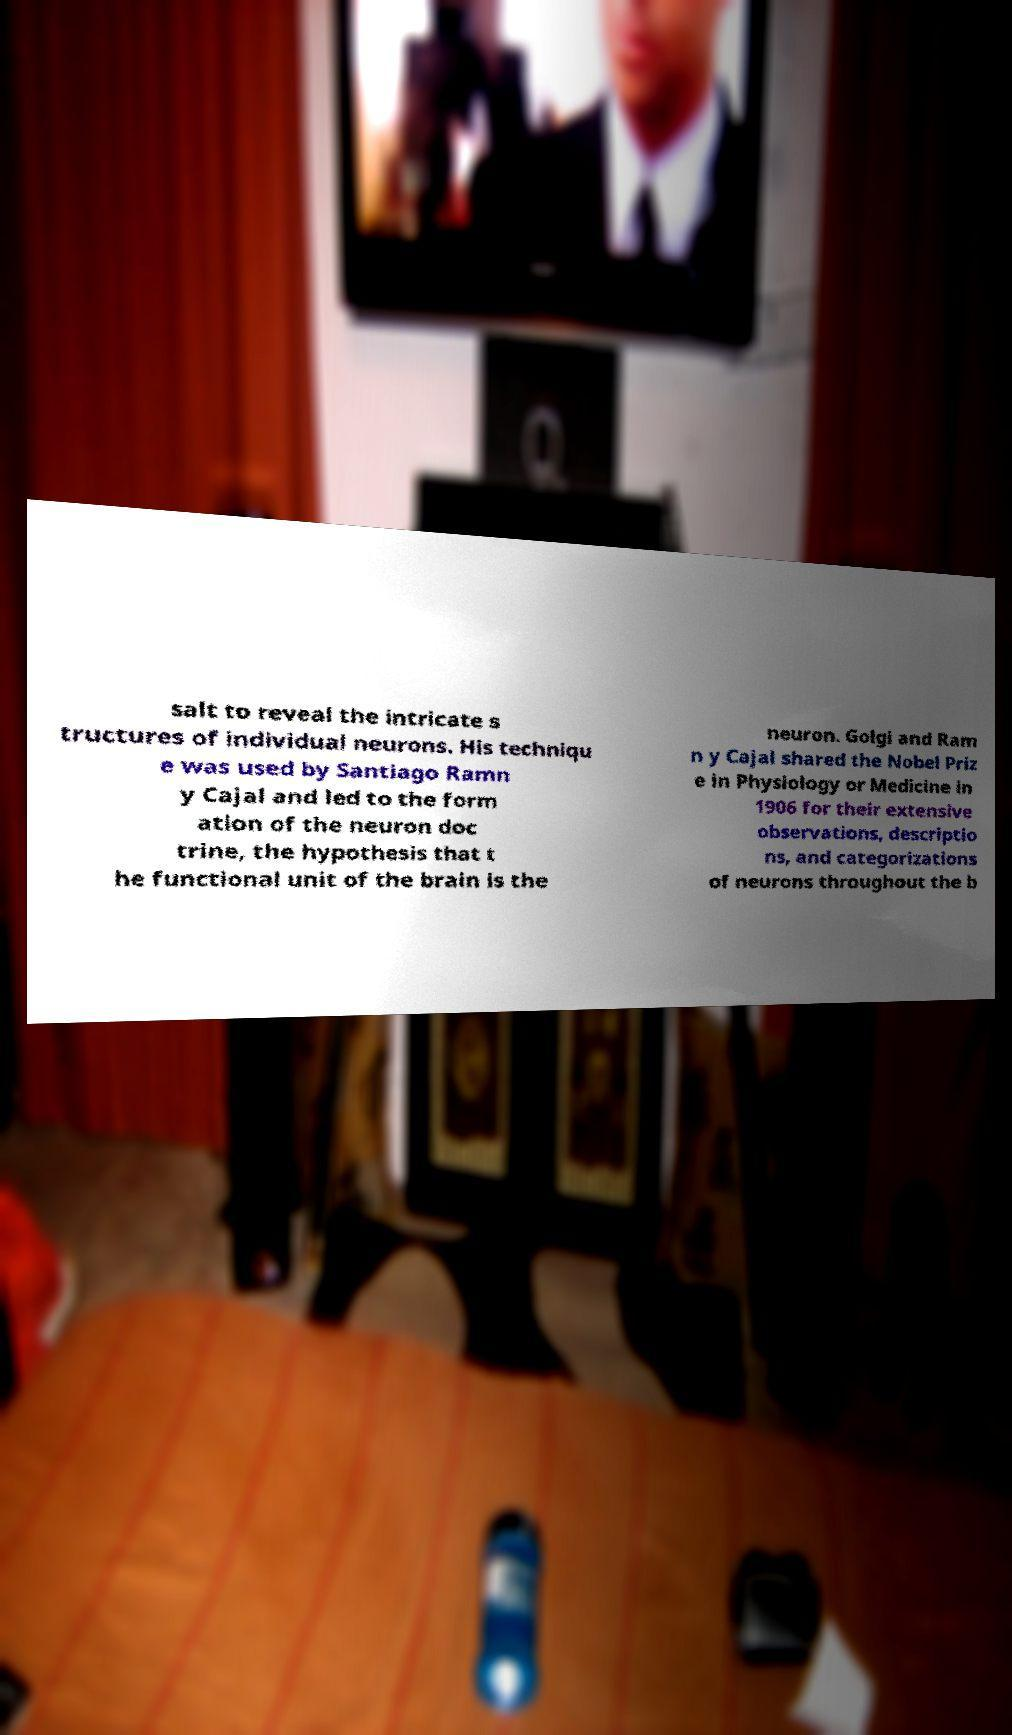Could you extract and type out the text from this image? salt to reveal the intricate s tructures of individual neurons. His techniqu e was used by Santiago Ramn y Cajal and led to the form ation of the neuron doc trine, the hypothesis that t he functional unit of the brain is the neuron. Golgi and Ram n y Cajal shared the Nobel Priz e in Physiology or Medicine in 1906 for their extensive observations, descriptio ns, and categorizations of neurons throughout the b 